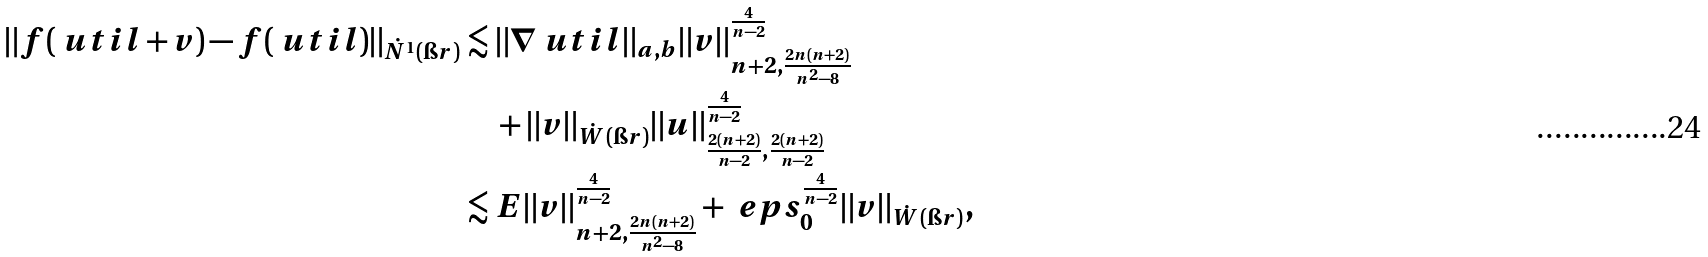Convert formula to latex. <formula><loc_0><loc_0><loc_500><loc_500>\| f ( \ u t i l + v ) - f ( \ u t i l ) \| _ { \dot { N } ^ { 1 } ( \i r ) } & \lesssim \| \nabla \ u t i l \| _ { a , b } \| v \| _ { n + 2 , \frac { 2 n ( n + 2 ) } { n ^ { 2 } - 8 } } ^ { \frac { 4 } { n - 2 } } \\ & \quad + \| v \| _ { \dot { W } ( \i r ) } \| u \| _ { \frac { 2 ( n + 2 ) } { n - 2 } , \frac { 2 ( n + 2 ) } { n - 2 } } ^ { \frac { 4 } { n - 2 } } \\ & \lesssim E \| v \| _ { n + 2 , \frac { 2 n ( n + 2 ) } { n ^ { 2 } - 8 } } ^ { \frac { 4 } { n - 2 } } + \ e p s _ { 0 } ^ { \frac { 4 } { n - 2 } } \| v \| _ { \dot { W } ( \i r ) } ,</formula> 